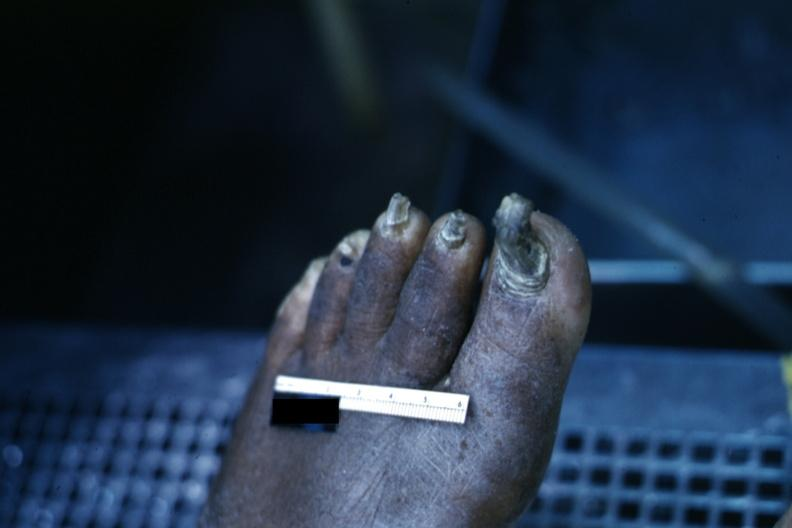what is present?
Answer the question using a single word or phrase. Foot 